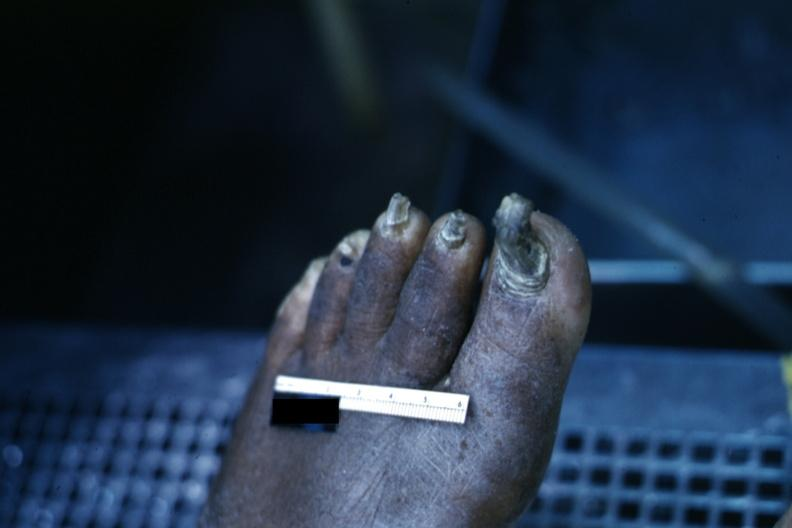what is present?
Answer the question using a single word or phrase. Foot 